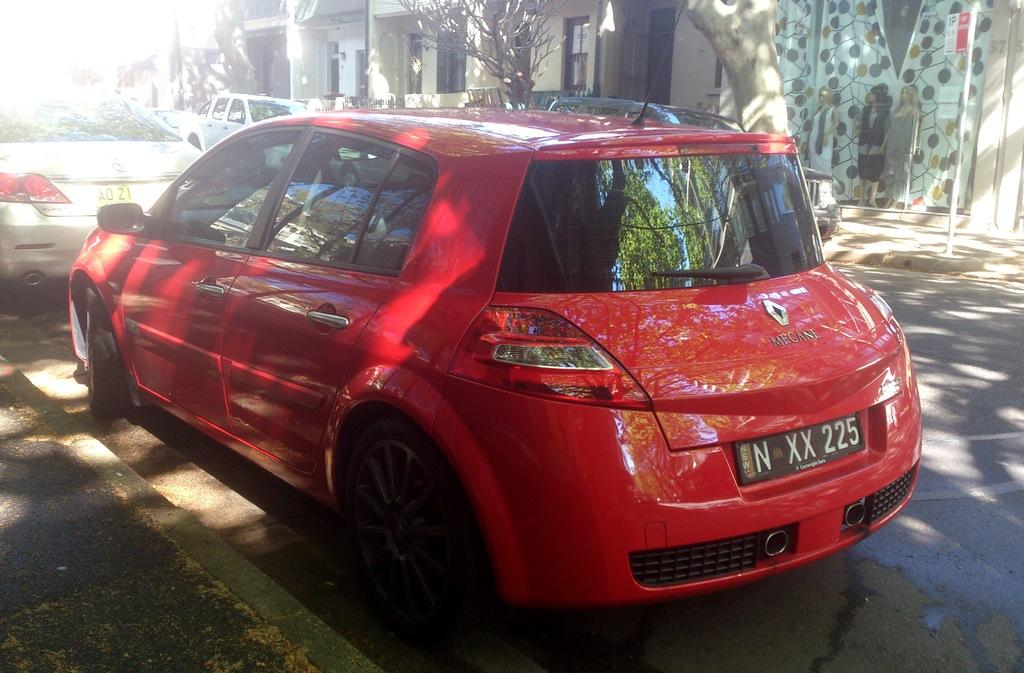What is the main subject of the image? The main subject of the image is cars on the road. Where are the cars located in the image? The cars are in the center of the image. What can be seen in the background of the image? There are trees and buildings in the background of the image. What type of field can be seen in the image? There is no field present in the image; it features cars on the road with trees and buildings in the background. 